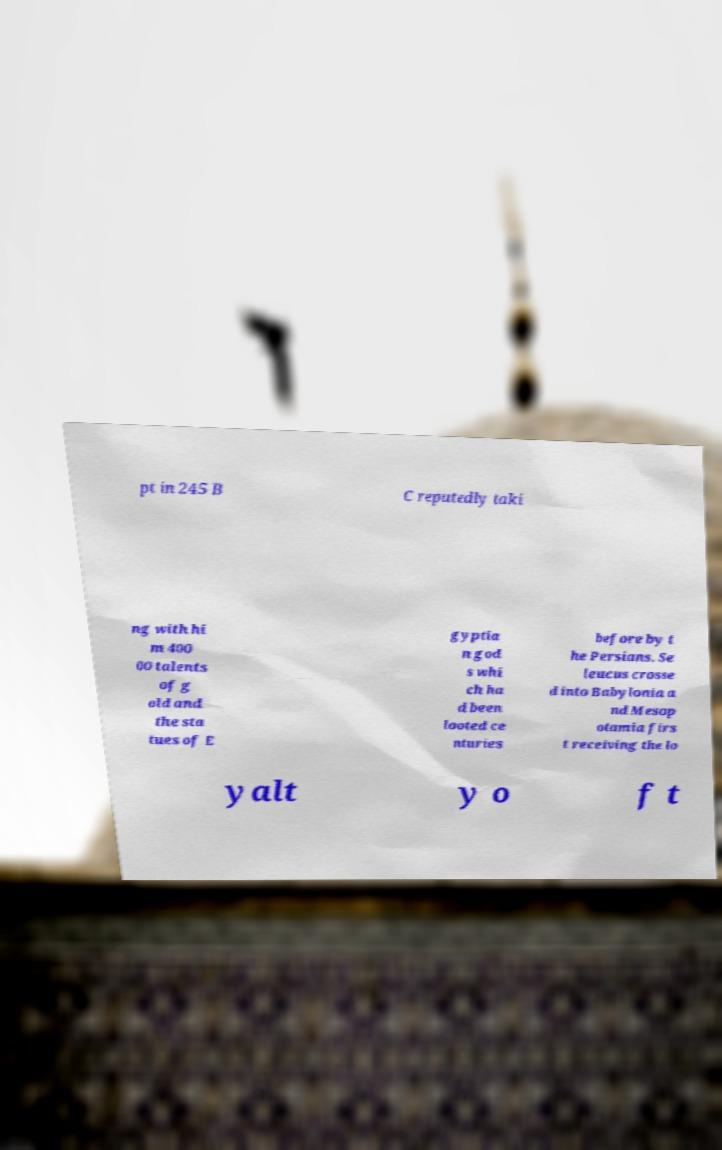Can you accurately transcribe the text from the provided image for me? pt in 245 B C reputedly taki ng with hi m 400 00 talents of g old and the sta tues of E gyptia n god s whi ch ha d been looted ce nturies before by t he Persians. Se leucus crosse d into Babylonia a nd Mesop otamia firs t receiving the lo yalt y o f t 